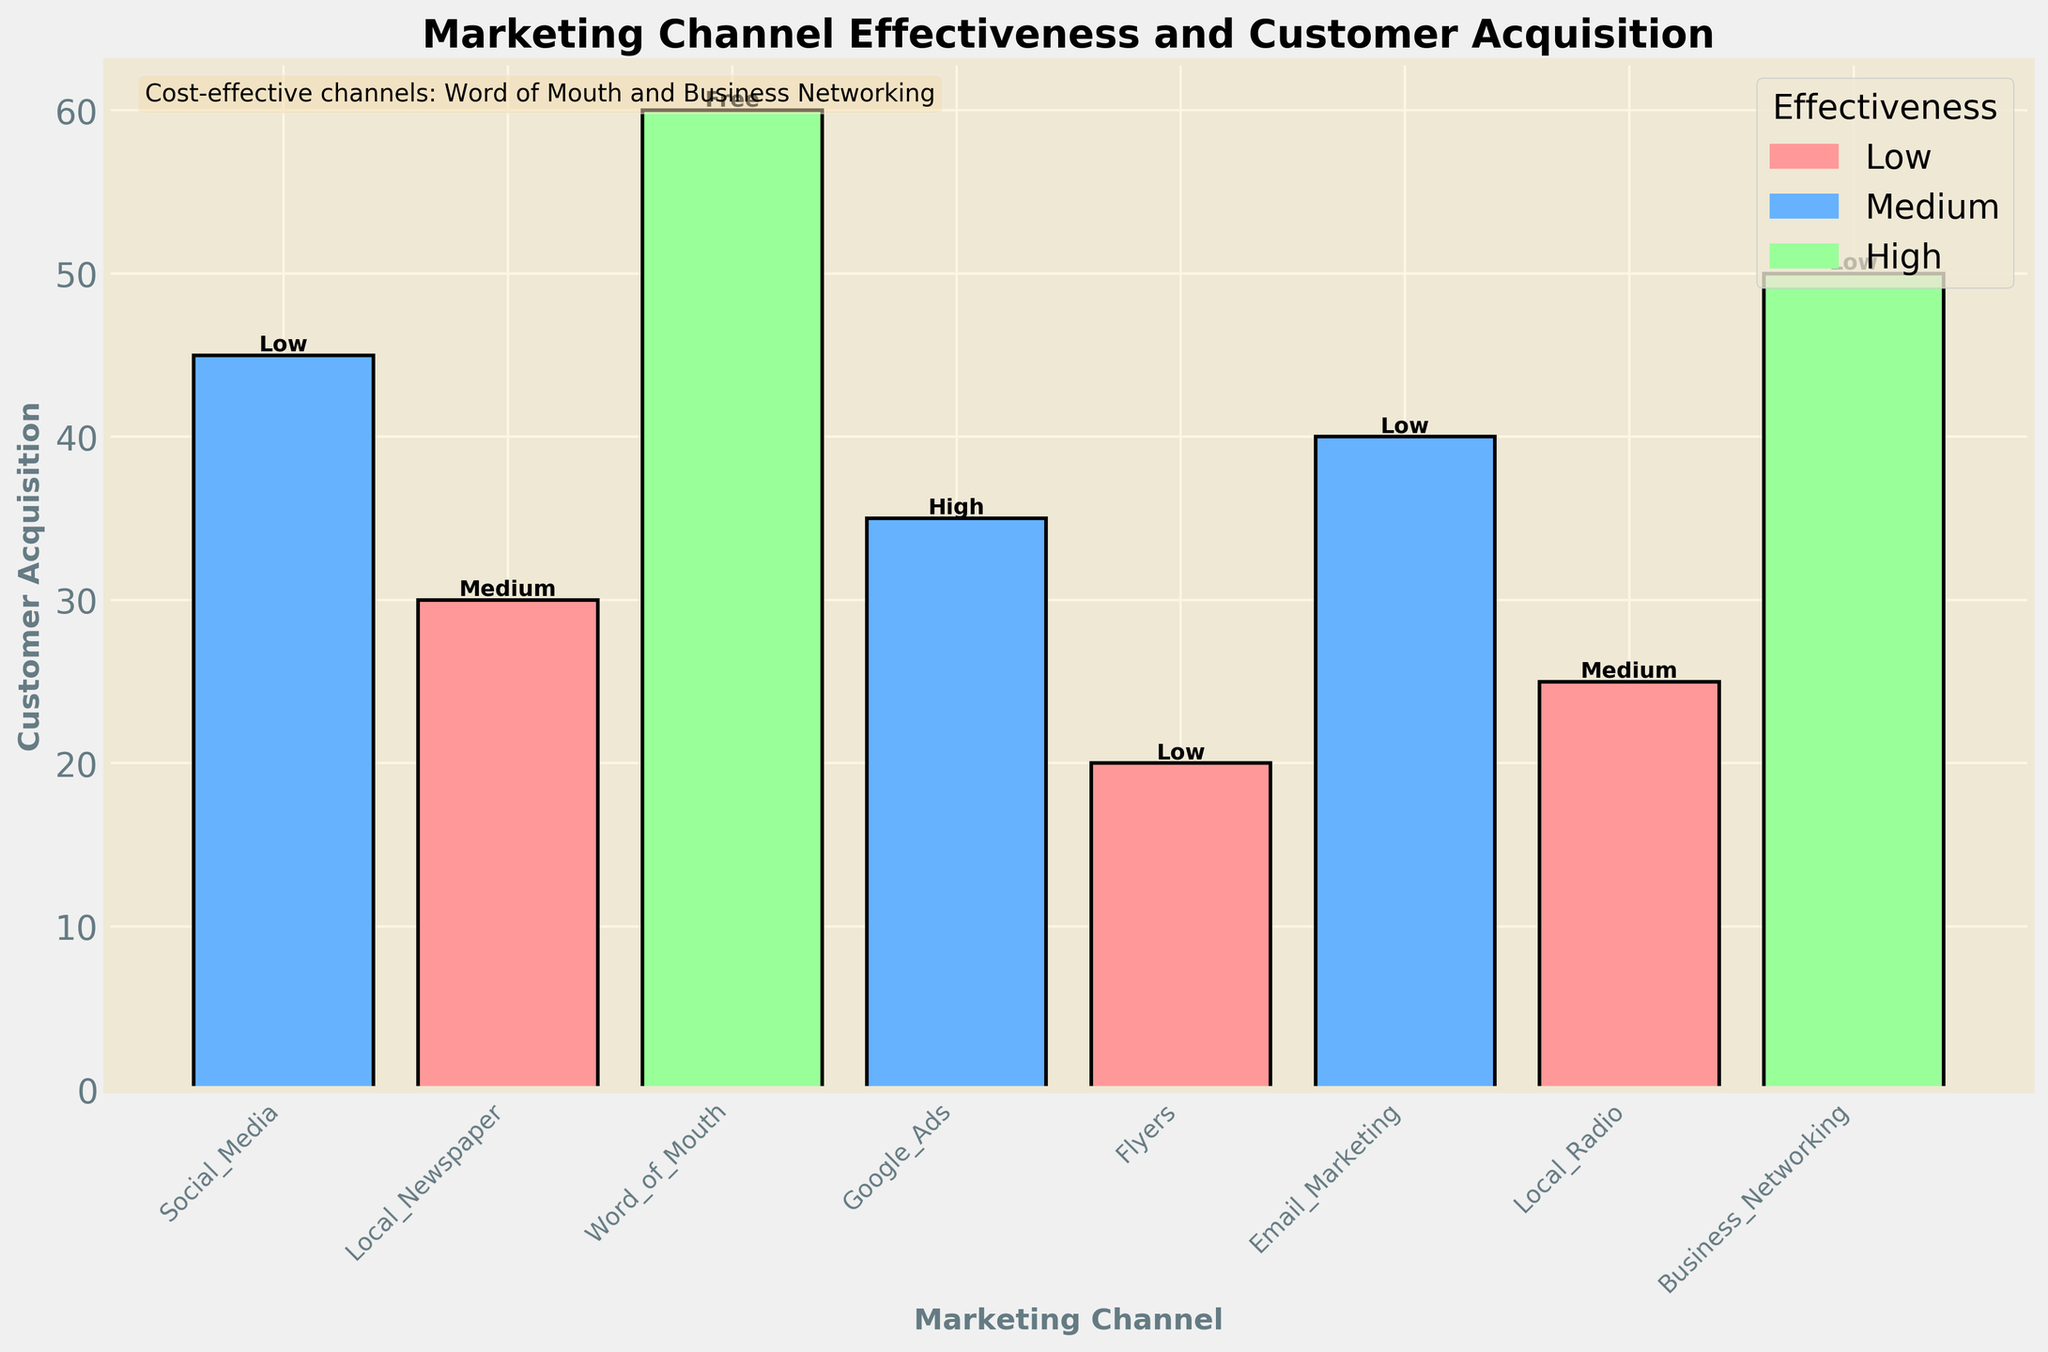What is the title of the plot? The title of the plot is found at the top and summarizes the content of the figure. It can be read directly from the figure.
Answer: Marketing Channel Effectiveness and Customer Acquisition Which marketing channel has the highest customer acquisition? Identify the tallest bar in the plot which correspond to the marketing channel with the highest customer acquisition.
Answer: Word of Mouth What is the effectiveness level of the Google Ads channel? Look at the bar labeled 'Google Ads' and identify its color, then refer to the legend to find the corresponding effectiveness level.
Answer: Medium How many marketing channels have a 'Low' cost range? Read the text labels on the bars that state the cost range and count how many bars have 'Low' cost.
Answer: Three What is the combined customer acquisition for Social Media and Email Marketing? Identify the bars for Social Media and Email Marketing, read their customer acquisition numbers, and add them together (45 + 40).
Answer: 85 Which marketing channel has the lowest customer acquisition and what is its effectiveness level? Identify the shortest bar to find the channel with the lowest customer acquisition, then check its color to determine the effectiveness level.
Answer: Flyers, Low Among the channels with a 'High' effectiveness level, which one has the higher customer acquisition? Identify bars with 'High' effectiveness (as indicated by the color corresponding to 'High' in the legend), then compare their customer acquisition numbers to determine the highest one.
Answer: Word of Mouth Comparing Local Newspaper and Local Radio, which has higher customer acquisition and what are their respective costs? Identify bars for Local Newspaper and Local Radio, compare the heights to see which one is taller (higher customer acquisition), and read the cost labels from both bars.
Answer: Local Newspaper, Medium (vs. Medium for Local Radio) Which marketing channels are suggested as cost-effective in the plot's annotation text? The annotation text in the plot provides specific recommendations about cost-effective channels, read and identify them directly from the text.
Answer: Word of Mouth and Business Networking How many marketing channels have a 'Low' effectiveness level? Refer to the legend to see which color corresponds to 'Low' effectiveness, then count all the bars of that color.
Answer: Three 